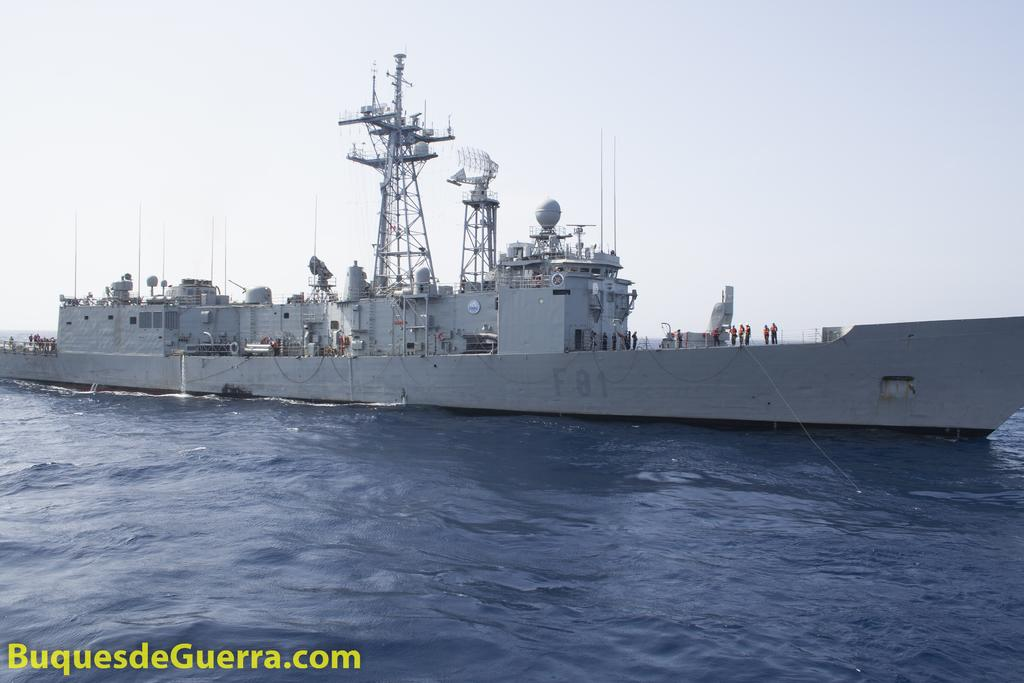What is the main subject of the image? The main subject of the image is a big ship. What color is the ship? The ship is white in color. Where is the ship located in the image? The ship is in the water. What can be seen on the left side of the ship? There is a website name on the left side of the ship. What is visible at the top of the image? The sky is visible at the top of the image. What is the price of the carpenter's services in the image? There is no carpenter or mention of services or prices in the image; it features a big white ship in the water. 